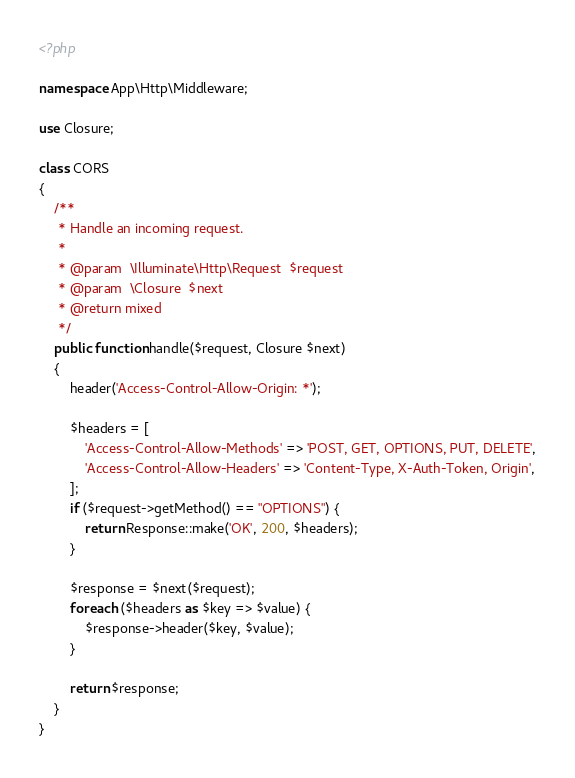Convert code to text. <code><loc_0><loc_0><loc_500><loc_500><_PHP_><?php

namespace App\Http\Middleware;

use Closure;

class CORS
{
    /**
     * Handle an incoming request.
     *
     * @param  \Illuminate\Http\Request  $request
     * @param  \Closure  $next
     * @return mixed
     */
    public function handle($request, Closure $next)
    {
        header('Access-Control-Allow-Origin: *');

        $headers = [
            'Access-Control-Allow-Methods' => 'POST, GET, OPTIONS, PUT, DELETE',
            'Access-Control-Allow-Headers' => 'Content-Type, X-Auth-Token, Origin',
        ];
        if ($request->getMethod() == "OPTIONS") {
            return Response::make('OK', 200, $headers);
        }

        $response = $next($request);
        foreach ($headers as $key => $value) {
            $response->header($key, $value);
        }

        return $response;
    }
}
</code> 